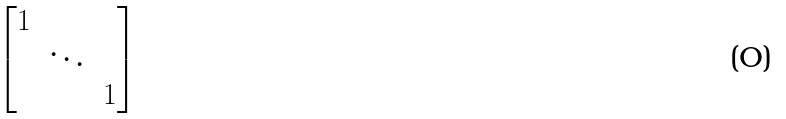Convert formula to latex. <formula><loc_0><loc_0><loc_500><loc_500>\begin{bmatrix} 1 & & \\ & \ddots & \\ & & 1 \end{bmatrix}</formula> 